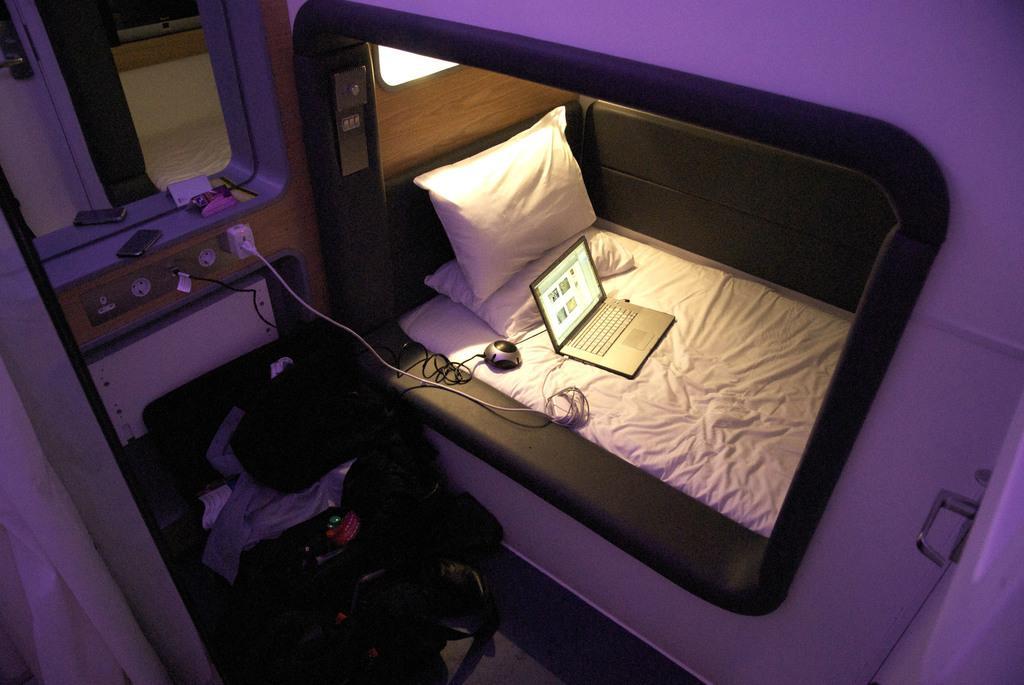Please provide a concise description of this image. In this image we can see the inner view of a cabin. In the cabin we can see there are mirrors, mobile phones, cables, charger sockets, electric switches, cot, pillows and bags that are placed on the floor. 